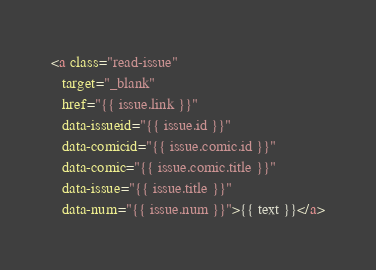<code> <loc_0><loc_0><loc_500><loc_500><_HTML_><a class="read-issue"
   target="_blank"
   href="{{ issue.link }}"
   data-issueid="{{ issue.id }}"
   data-comicid="{{ issue.comic.id }}"
   data-comic="{{ issue.comic.title }}"
   data-issue="{{ issue.title }}"
   data-num="{{ issue.num }}">{{ text }}</a>
</code> 